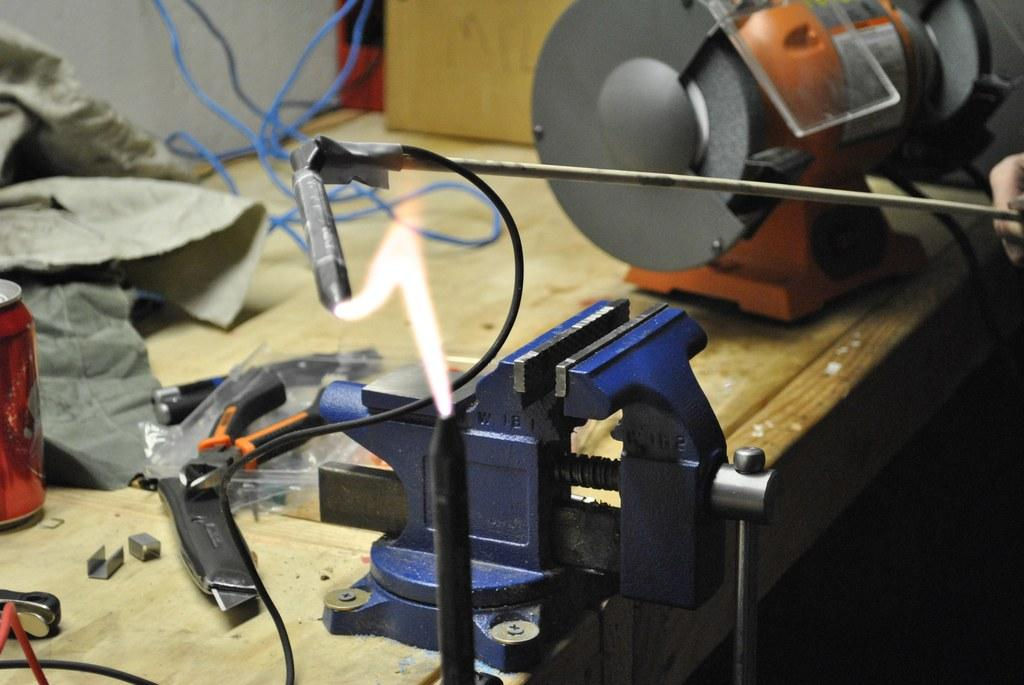What types of objects can be seen in the image? There are machines and instruments in the image. What is on the table in the image? There is a can on the table in the image. What is the human hand holding in the image? A human hand is holding a metal rod in the image. What is the source of heat or light in the image? There is fire in the image. What type of tent can be seen in the image? There is no tent present in the image. 